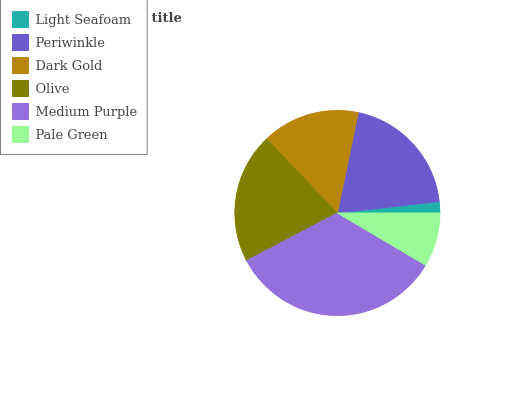Is Light Seafoam the minimum?
Answer yes or no. Yes. Is Medium Purple the maximum?
Answer yes or no. Yes. Is Periwinkle the minimum?
Answer yes or no. No. Is Periwinkle the maximum?
Answer yes or no. No. Is Periwinkle greater than Light Seafoam?
Answer yes or no. Yes. Is Light Seafoam less than Periwinkle?
Answer yes or no. Yes. Is Light Seafoam greater than Periwinkle?
Answer yes or no. No. Is Periwinkle less than Light Seafoam?
Answer yes or no. No. Is Periwinkle the high median?
Answer yes or no. Yes. Is Dark Gold the low median?
Answer yes or no. Yes. Is Medium Purple the high median?
Answer yes or no. No. Is Light Seafoam the low median?
Answer yes or no. No. 